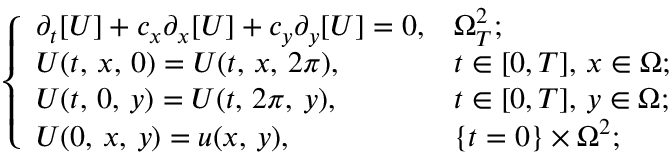<formula> <loc_0><loc_0><loc_500><loc_500>\left \{ \begin{array} { l l } { \partial _ { t } [ U ] + c _ { x } \partial _ { x } [ U ] + c _ { y } \partial _ { y } [ U ] = 0 , } & { \Omega _ { T } ^ { 2 } ; } \\ { U ( t , \, x , \, 0 ) = U ( t , \, x , \, 2 \pi ) , } & { t \in [ 0 , T ] , \, x \in \Omega ; } \\ { U ( t , \, 0 , \, y ) = U ( t , \, 2 \pi , \, y ) , } & { t \in [ 0 , T ] , \, y \in \Omega ; } \\ { U ( 0 , \, x , \, y ) = u ( x , \, y ) , } & { \{ t = 0 \} \times \Omega ^ { 2 } ; } \end{array}</formula> 